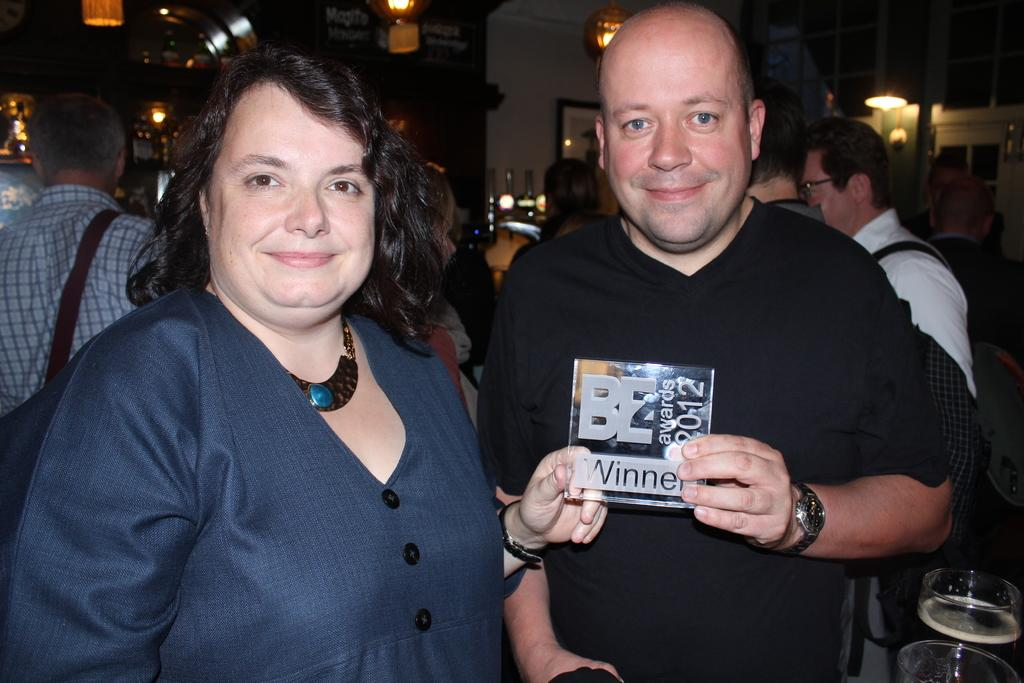How many people are present in the image? There are two people, a man and a woman, present in the image. What are the man and woman doing in the image? The man and woman are standing and holding an object. Can you describe the people in the background of the image? There are people in the background of the image, but their specific actions or features are not mentioned in the provided facts. What type of snake can be seen slithering in the image? There is no snake present in the image. Is the object being held by the man and woman a toy? The provided facts do not mention the nature of the object being held by the man and woman, so we cannot determine if it is a toy or not. 